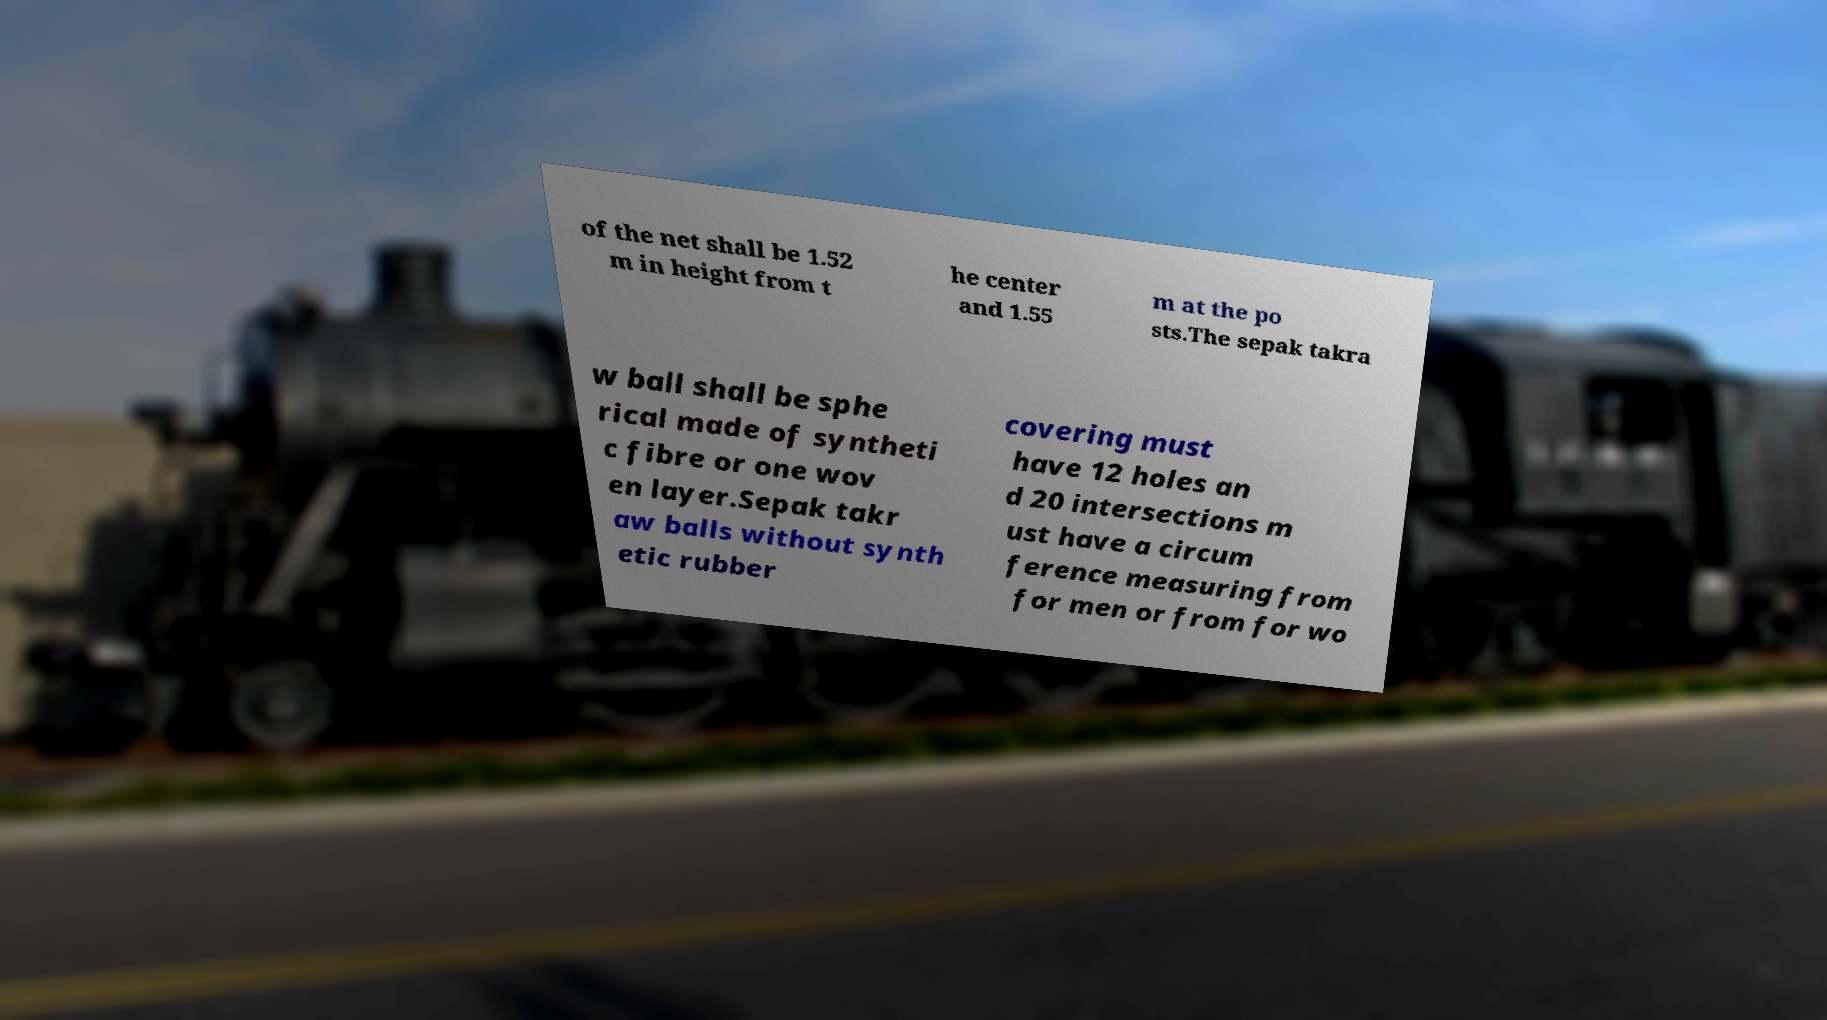What messages or text are displayed in this image? I need them in a readable, typed format. of the net shall be 1.52 m in height from t he center and 1.55 m at the po sts.The sepak takra w ball shall be sphe rical made of syntheti c fibre or one wov en layer.Sepak takr aw balls without synth etic rubber covering must have 12 holes an d 20 intersections m ust have a circum ference measuring from for men or from for wo 